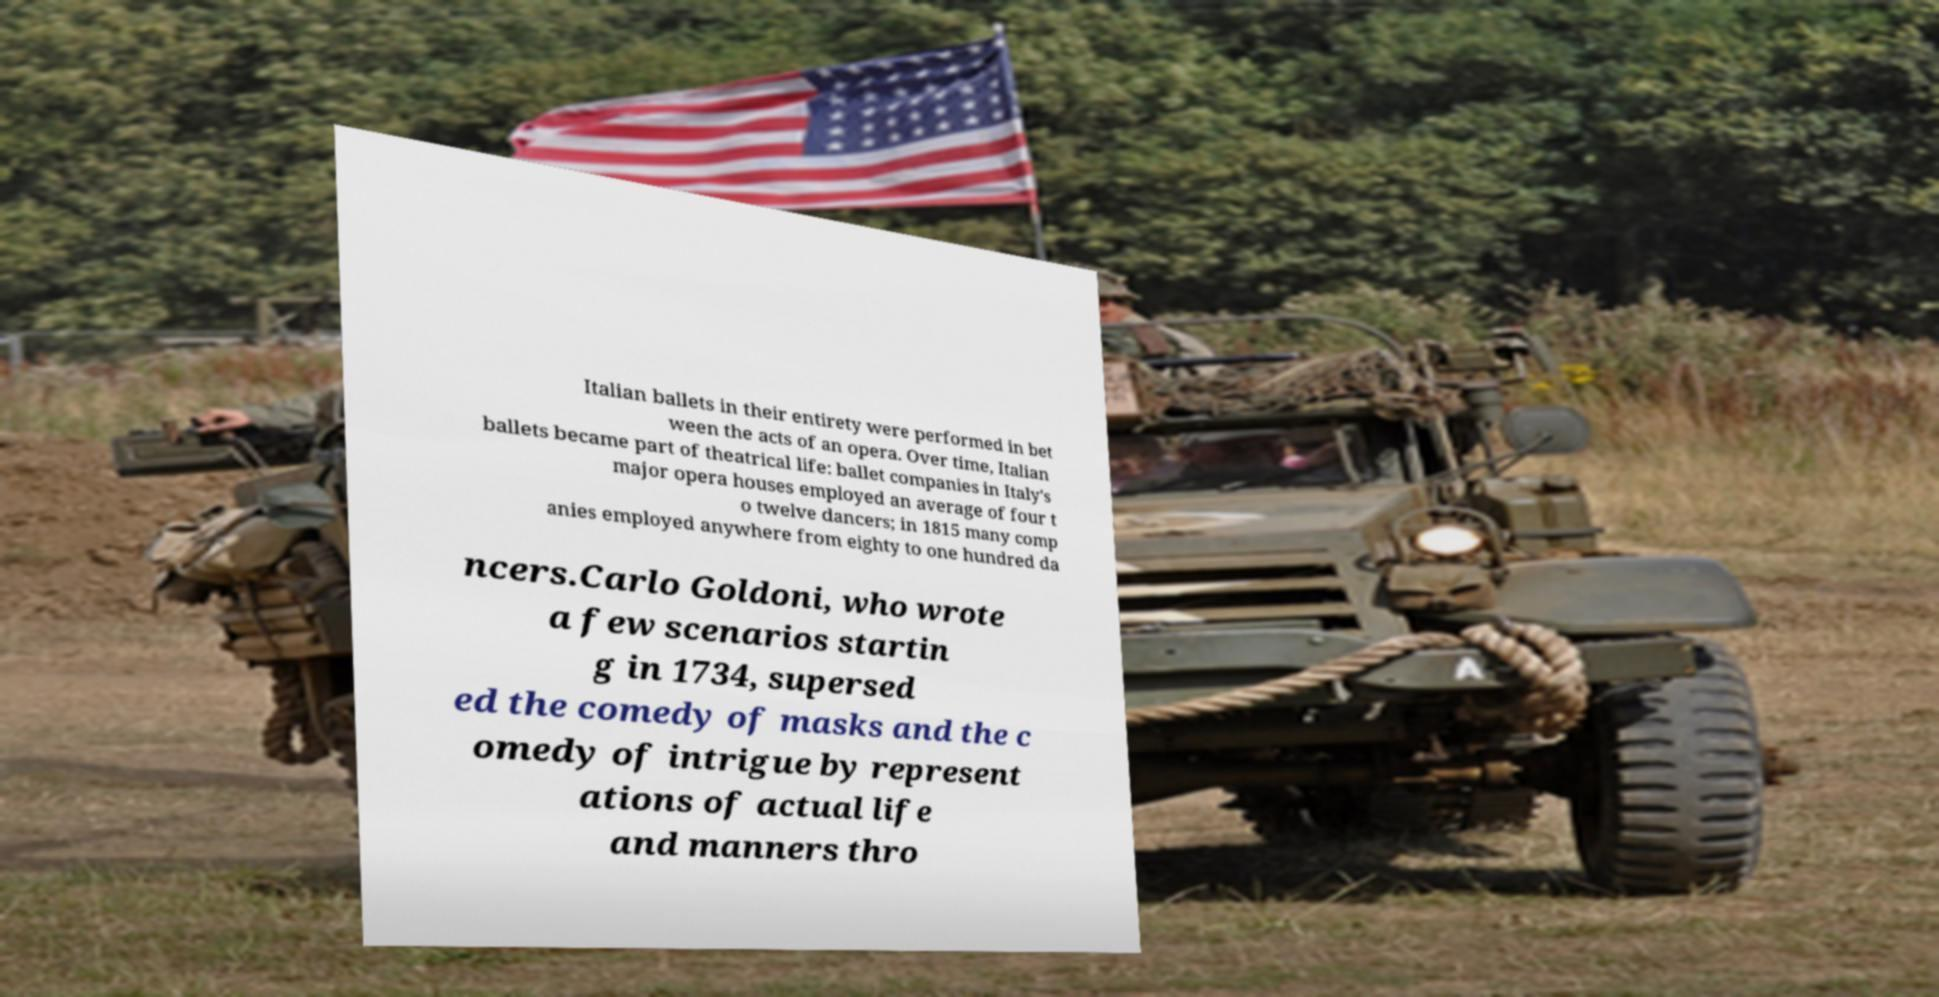Please identify and transcribe the text found in this image. Italian ballets in their entirety were performed in bet ween the acts of an opera. Over time, Italian ballets became part of theatrical life: ballet companies in Italy's major opera houses employed an average of four t o twelve dancers; in 1815 many comp anies employed anywhere from eighty to one hundred da ncers.Carlo Goldoni, who wrote a few scenarios startin g in 1734, supersed ed the comedy of masks and the c omedy of intrigue by represent ations of actual life and manners thro 